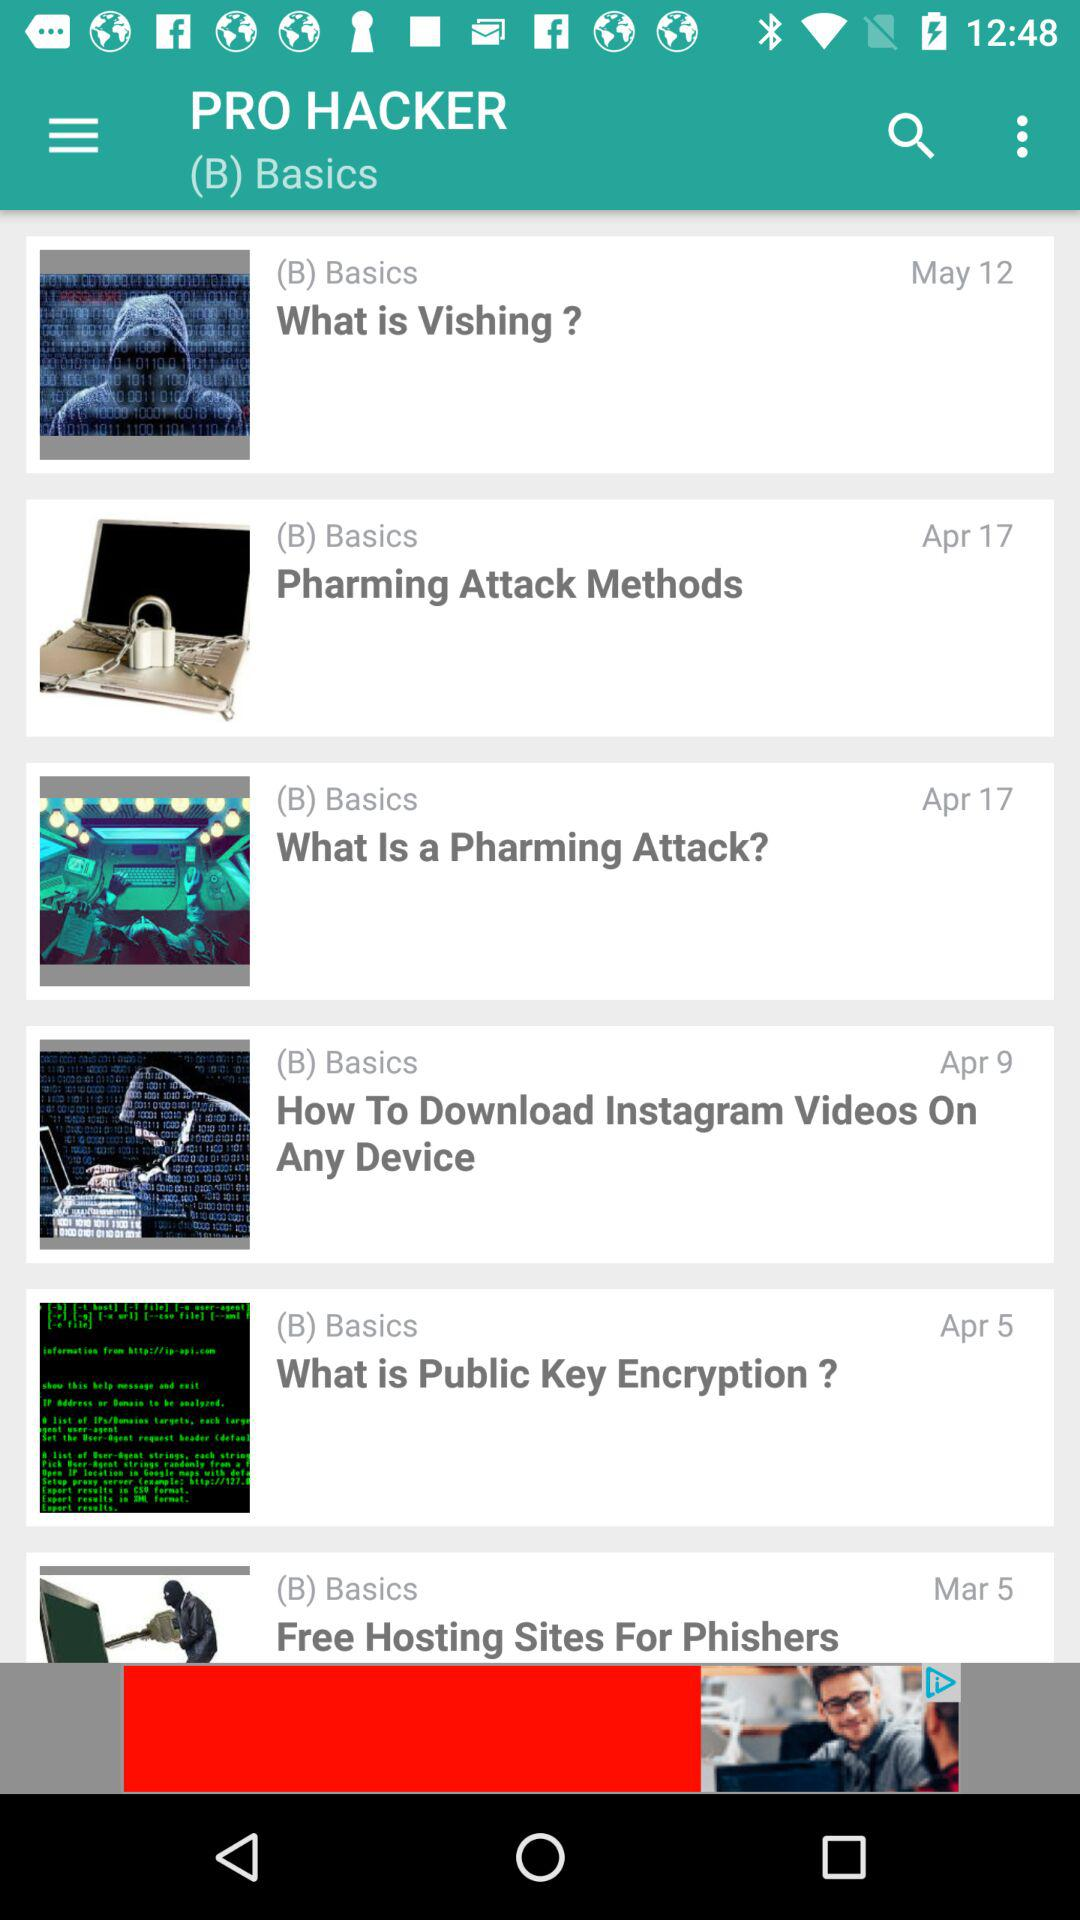What is the date mentioned for "Pharming Attack Methods"? The date mentioned for "Pharming Attack Methods" is April 17. 